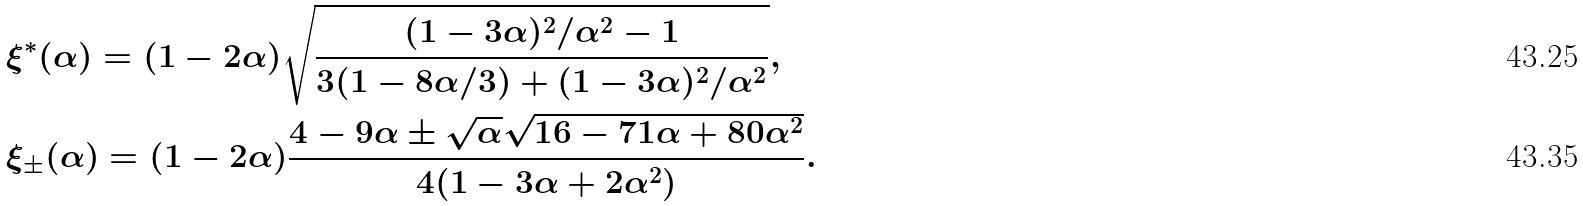<formula> <loc_0><loc_0><loc_500><loc_500>& \xi ^ { * } ( \alpha ) = ( 1 - 2 \alpha ) \sqrt { \frac { ( 1 - 3 \alpha ) ^ { 2 } / \alpha ^ { 2 } - 1 } { 3 ( 1 - 8 \alpha / 3 ) + ( 1 - 3 \alpha ) ^ { 2 } / \alpha ^ { 2 } } } , \\ & \xi _ { \pm } ( \alpha ) = ( 1 - 2 \alpha ) \frac { 4 - 9 \alpha \pm \sqrt { \alpha } \sqrt { 1 6 - 7 1 \alpha + 8 0 \alpha ^ { 2 } } } { 4 ( 1 - 3 \alpha + 2 \alpha ^ { 2 } ) } .</formula> 